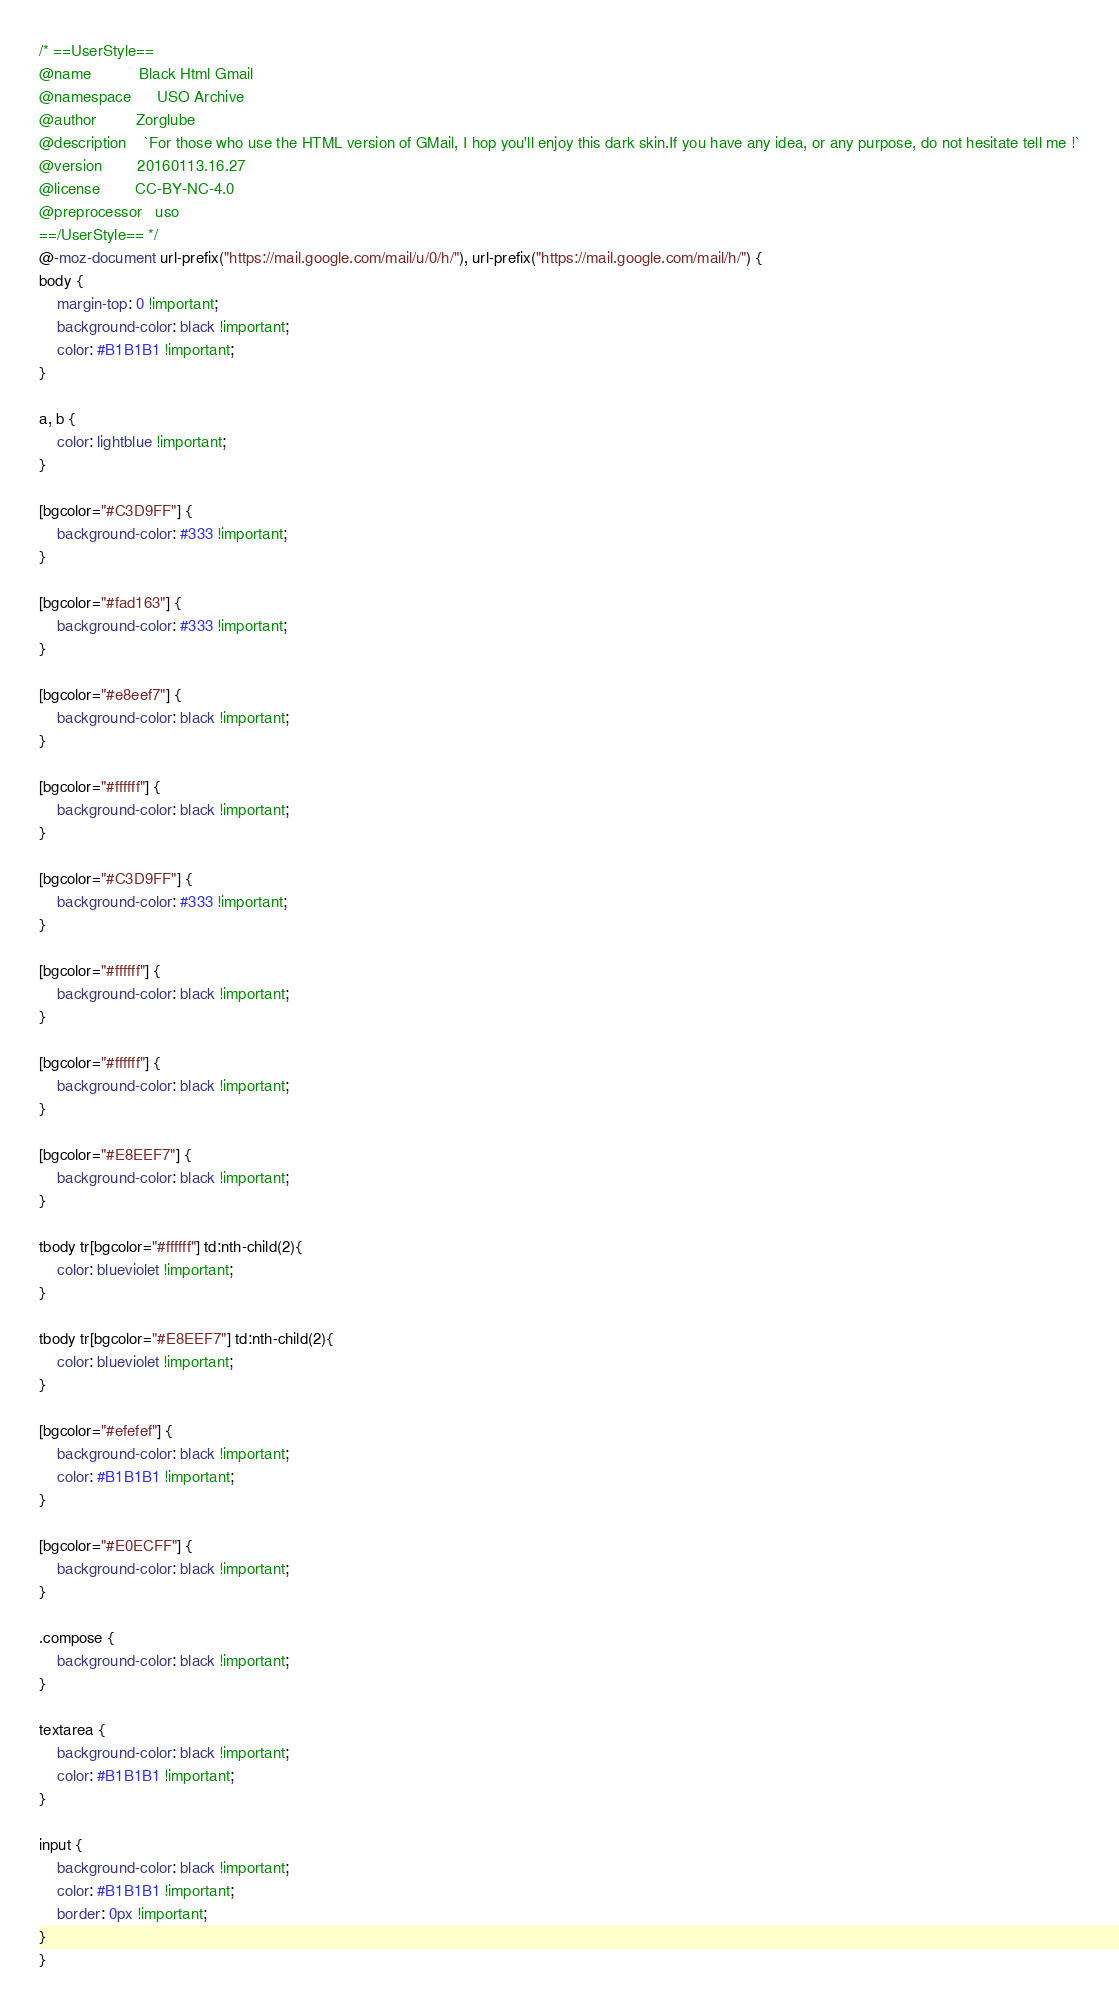Convert code to text. <code><loc_0><loc_0><loc_500><loc_500><_CSS_>/* ==UserStyle==
@name           Black Html Gmail
@namespace      USO Archive
@author         Zorglube
@description    `For those who use the HTML version of GMail, I hop you'll enjoy this dark skin.If you have any idea, or any purpose, do not hesitate tell me !`
@version        20160113.16.27
@license        CC-BY-NC-4.0
@preprocessor   uso
==/UserStyle== */
@-moz-document url-prefix("https://mail.google.com/mail/u/0/h/"), url-prefix("https://mail.google.com/mail/h/") {
body {
    margin-top: 0 !important;
    background-color: black !important;
	color: #B1B1B1 !important; 
}

a, b {
	color: lightblue !important; 
}

[bgcolor="#C3D9FF"] { 
	background-color: #333 !important; 
}

[bgcolor="#fad163"] { 
	background-color: #333 !important; 
}

[bgcolor="#e8eef7"] { 
	background-color: black !important; 
}

[bgcolor="#ffffff"] {
	background-color: black !important; 
}

[bgcolor="#C3D9FF"] {
	background-color: #333 !important; 
}

[bgcolor="#ffffff"] {
	background-color: black !important; 
}

[bgcolor="#ffffff"] {
	background-color: black !important; 
}

[bgcolor="#E8EEF7"] {
	background-color: black !important; 
}

tbody tr[bgcolor="#ffffff"] td:nth-child(2){
	color: blueviolet !important;  
}

tbody tr[bgcolor="#E8EEF7"] td:nth-child(2){
	color: blueviolet !important;  
}

[bgcolor="#efefef"] {
	background-color: black !important; 
	color: #B1B1B1 !important; 
}

[bgcolor="#E0ECFF"] {
	background-color: black !important; 
}

.compose {
	background-color: black !important; 
}

textarea {
	background-color: black !important;	
	color: #B1B1B1 !important; 
}

input {
	background-color: black !important; 
	color: #B1B1B1 !important; 
	border: 0px !important; 
}
}</code> 